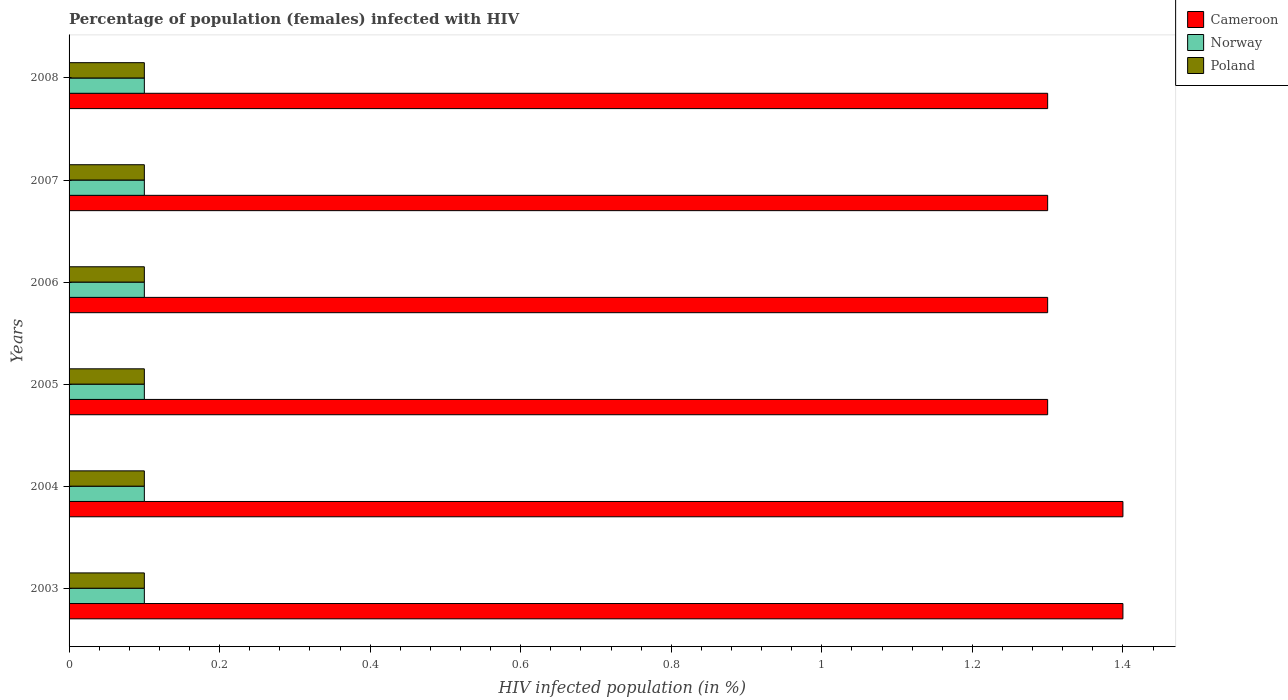How many different coloured bars are there?
Make the answer very short. 3. Are the number of bars per tick equal to the number of legend labels?
Provide a short and direct response. Yes. How many bars are there on the 1st tick from the top?
Provide a short and direct response. 3. What is the percentage of HIV infected female population in Norway in 2007?
Your answer should be compact. 0.1. In which year was the percentage of HIV infected female population in Poland maximum?
Your answer should be very brief. 2003. What is the total percentage of HIV infected female population in Cameroon in the graph?
Offer a very short reply. 8. What is the difference between the percentage of HIV infected female population in Norway in 2004 and the percentage of HIV infected female population in Poland in 2006?
Keep it short and to the point. 0. What is the average percentage of HIV infected female population in Norway per year?
Give a very brief answer. 0.1. In the year 2006, what is the difference between the percentage of HIV infected female population in Poland and percentage of HIV infected female population in Norway?
Offer a very short reply. 0. In how many years, is the percentage of HIV infected female population in Norway greater than 0.9600000000000001 %?
Your answer should be compact. 0. What is the ratio of the percentage of HIV infected female population in Cameroon in 2003 to that in 2005?
Ensure brevity in your answer.  1.08. Is the percentage of HIV infected female population in Cameroon in 2004 less than that in 2007?
Your answer should be very brief. No. Is the difference between the percentage of HIV infected female population in Poland in 2004 and 2008 greater than the difference between the percentage of HIV infected female population in Norway in 2004 and 2008?
Ensure brevity in your answer.  No. What is the difference between the highest and the lowest percentage of HIV infected female population in Cameroon?
Make the answer very short. 0.1. In how many years, is the percentage of HIV infected female population in Poland greater than the average percentage of HIV infected female population in Poland taken over all years?
Your answer should be very brief. 6. Is the sum of the percentage of HIV infected female population in Poland in 2005 and 2008 greater than the maximum percentage of HIV infected female population in Cameroon across all years?
Give a very brief answer. No. What does the 3rd bar from the top in 2008 represents?
Your response must be concise. Cameroon. Is it the case that in every year, the sum of the percentage of HIV infected female population in Norway and percentage of HIV infected female population in Poland is greater than the percentage of HIV infected female population in Cameroon?
Provide a short and direct response. No. How many bars are there?
Your answer should be compact. 18. Are all the bars in the graph horizontal?
Keep it short and to the point. Yes. How many years are there in the graph?
Offer a very short reply. 6. What is the difference between two consecutive major ticks on the X-axis?
Make the answer very short. 0.2. Does the graph contain grids?
Offer a terse response. No. Where does the legend appear in the graph?
Give a very brief answer. Top right. How many legend labels are there?
Provide a succinct answer. 3. How are the legend labels stacked?
Provide a short and direct response. Vertical. What is the title of the graph?
Your response must be concise. Percentage of population (females) infected with HIV. What is the label or title of the X-axis?
Give a very brief answer. HIV infected population (in %). What is the HIV infected population (in %) of Cameroon in 2004?
Ensure brevity in your answer.  1.4. What is the HIV infected population (in %) of Norway in 2004?
Give a very brief answer. 0.1. What is the HIV infected population (in %) in Poland in 2004?
Your response must be concise. 0.1. What is the HIV infected population (in %) in Cameroon in 2005?
Provide a short and direct response. 1.3. What is the HIV infected population (in %) of Norway in 2005?
Make the answer very short. 0.1. What is the HIV infected population (in %) of Poland in 2005?
Offer a very short reply. 0.1. What is the HIV infected population (in %) of Poland in 2006?
Your answer should be compact. 0.1. What is the HIV infected population (in %) of Poland in 2007?
Make the answer very short. 0.1. What is the HIV infected population (in %) in Norway in 2008?
Give a very brief answer. 0.1. Across all years, what is the maximum HIV infected population (in %) in Poland?
Offer a very short reply. 0.1. Across all years, what is the minimum HIV infected population (in %) of Norway?
Provide a succinct answer. 0.1. Across all years, what is the minimum HIV infected population (in %) of Poland?
Your answer should be compact. 0.1. What is the total HIV infected population (in %) of Norway in the graph?
Provide a succinct answer. 0.6. What is the difference between the HIV infected population (in %) in Cameroon in 2003 and that in 2004?
Provide a short and direct response. 0. What is the difference between the HIV infected population (in %) of Norway in 2003 and that in 2004?
Offer a terse response. 0. What is the difference between the HIV infected population (in %) of Cameroon in 2003 and that in 2005?
Provide a succinct answer. 0.1. What is the difference between the HIV infected population (in %) in Poland in 2003 and that in 2005?
Your answer should be compact. 0. What is the difference between the HIV infected population (in %) of Norway in 2003 and that in 2006?
Offer a terse response. 0. What is the difference between the HIV infected population (in %) of Poland in 2003 and that in 2006?
Keep it short and to the point. 0. What is the difference between the HIV infected population (in %) of Norway in 2003 and that in 2007?
Make the answer very short. 0. What is the difference between the HIV infected population (in %) in Cameroon in 2003 and that in 2008?
Your answer should be very brief. 0.1. What is the difference between the HIV infected population (in %) of Norway in 2003 and that in 2008?
Ensure brevity in your answer.  0. What is the difference between the HIV infected population (in %) in Cameroon in 2004 and that in 2005?
Ensure brevity in your answer.  0.1. What is the difference between the HIV infected population (in %) of Poland in 2004 and that in 2005?
Your answer should be compact. 0. What is the difference between the HIV infected population (in %) in Cameroon in 2004 and that in 2006?
Your answer should be very brief. 0.1. What is the difference between the HIV infected population (in %) of Poland in 2004 and that in 2006?
Give a very brief answer. 0. What is the difference between the HIV infected population (in %) of Cameroon in 2004 and that in 2007?
Offer a terse response. 0.1. What is the difference between the HIV infected population (in %) of Norway in 2004 and that in 2007?
Make the answer very short. 0. What is the difference between the HIV infected population (in %) of Norway in 2004 and that in 2008?
Ensure brevity in your answer.  0. What is the difference between the HIV infected population (in %) in Poland in 2004 and that in 2008?
Keep it short and to the point. 0. What is the difference between the HIV infected population (in %) in Cameroon in 2005 and that in 2006?
Your answer should be compact. 0. What is the difference between the HIV infected population (in %) in Norway in 2005 and that in 2006?
Your answer should be very brief. 0. What is the difference between the HIV infected population (in %) in Poland in 2005 and that in 2006?
Offer a very short reply. 0. What is the difference between the HIV infected population (in %) of Norway in 2005 and that in 2007?
Your answer should be very brief. 0. What is the difference between the HIV infected population (in %) of Cameroon in 2005 and that in 2008?
Provide a succinct answer. 0. What is the difference between the HIV infected population (in %) of Norway in 2005 and that in 2008?
Offer a terse response. 0. What is the difference between the HIV infected population (in %) of Poland in 2005 and that in 2008?
Offer a terse response. 0. What is the difference between the HIV infected population (in %) of Cameroon in 2006 and that in 2007?
Your answer should be compact. 0. What is the difference between the HIV infected population (in %) in Norway in 2006 and that in 2007?
Offer a very short reply. 0. What is the difference between the HIV infected population (in %) of Cameroon in 2007 and that in 2008?
Provide a short and direct response. 0. What is the difference between the HIV infected population (in %) in Norway in 2007 and that in 2008?
Offer a terse response. 0. What is the difference between the HIV infected population (in %) in Cameroon in 2003 and the HIV infected population (in %) in Norway in 2004?
Offer a terse response. 1.3. What is the difference between the HIV infected population (in %) of Norway in 2003 and the HIV infected population (in %) of Poland in 2004?
Provide a succinct answer. 0. What is the difference between the HIV infected population (in %) of Cameroon in 2003 and the HIV infected population (in %) of Norway in 2006?
Your response must be concise. 1.3. What is the difference between the HIV infected population (in %) of Cameroon in 2003 and the HIV infected population (in %) of Poland in 2006?
Offer a terse response. 1.3. What is the difference between the HIV infected population (in %) in Norway in 2003 and the HIV infected population (in %) in Poland in 2006?
Your response must be concise. 0. What is the difference between the HIV infected population (in %) of Cameroon in 2003 and the HIV infected population (in %) of Norway in 2007?
Give a very brief answer. 1.3. What is the difference between the HIV infected population (in %) of Norway in 2003 and the HIV infected population (in %) of Poland in 2007?
Your answer should be compact. 0. What is the difference between the HIV infected population (in %) in Cameroon in 2003 and the HIV infected population (in %) in Poland in 2008?
Your response must be concise. 1.3. What is the difference between the HIV infected population (in %) of Norway in 2004 and the HIV infected population (in %) of Poland in 2005?
Offer a very short reply. 0. What is the difference between the HIV infected population (in %) of Cameroon in 2004 and the HIV infected population (in %) of Norway in 2006?
Your response must be concise. 1.3. What is the difference between the HIV infected population (in %) of Norway in 2004 and the HIV infected population (in %) of Poland in 2006?
Give a very brief answer. 0. What is the difference between the HIV infected population (in %) of Cameroon in 2004 and the HIV infected population (in %) of Norway in 2007?
Your answer should be very brief. 1.3. What is the difference between the HIV infected population (in %) in Cameroon in 2004 and the HIV infected population (in %) in Poland in 2007?
Offer a terse response. 1.3. What is the difference between the HIV infected population (in %) in Cameroon in 2004 and the HIV infected population (in %) in Poland in 2008?
Ensure brevity in your answer.  1.3. What is the difference between the HIV infected population (in %) in Norway in 2004 and the HIV infected population (in %) in Poland in 2008?
Make the answer very short. 0. What is the difference between the HIV infected population (in %) of Cameroon in 2005 and the HIV infected population (in %) of Poland in 2006?
Your answer should be compact. 1.2. What is the difference between the HIV infected population (in %) in Norway in 2005 and the HIV infected population (in %) in Poland in 2006?
Provide a short and direct response. 0. What is the difference between the HIV infected population (in %) of Cameroon in 2005 and the HIV infected population (in %) of Poland in 2007?
Give a very brief answer. 1.2. What is the difference between the HIV infected population (in %) in Norway in 2005 and the HIV infected population (in %) in Poland in 2007?
Offer a terse response. 0. What is the difference between the HIV infected population (in %) in Cameroon in 2005 and the HIV infected population (in %) in Poland in 2008?
Keep it short and to the point. 1.2. What is the difference between the HIV infected population (in %) of Cameroon in 2006 and the HIV infected population (in %) of Norway in 2007?
Keep it short and to the point. 1.2. What is the difference between the HIV infected population (in %) in Cameroon in 2006 and the HIV infected population (in %) in Norway in 2008?
Provide a succinct answer. 1.2. What is the difference between the HIV infected population (in %) of Cameroon in 2007 and the HIV infected population (in %) of Poland in 2008?
Offer a terse response. 1.2. What is the average HIV infected population (in %) in Poland per year?
Provide a short and direct response. 0.1. In the year 2003, what is the difference between the HIV infected population (in %) of Norway and HIV infected population (in %) of Poland?
Ensure brevity in your answer.  0. In the year 2004, what is the difference between the HIV infected population (in %) in Cameroon and HIV infected population (in %) in Poland?
Your answer should be compact. 1.3. In the year 2005, what is the difference between the HIV infected population (in %) in Cameroon and HIV infected population (in %) in Norway?
Offer a terse response. 1.2. In the year 2005, what is the difference between the HIV infected population (in %) in Norway and HIV infected population (in %) in Poland?
Keep it short and to the point. 0. In the year 2006, what is the difference between the HIV infected population (in %) of Cameroon and HIV infected population (in %) of Poland?
Give a very brief answer. 1.2. In the year 2006, what is the difference between the HIV infected population (in %) of Norway and HIV infected population (in %) of Poland?
Your answer should be very brief. 0. In the year 2007, what is the difference between the HIV infected population (in %) in Cameroon and HIV infected population (in %) in Norway?
Your answer should be very brief. 1.2. In the year 2007, what is the difference between the HIV infected population (in %) in Cameroon and HIV infected population (in %) in Poland?
Your answer should be very brief. 1.2. In the year 2008, what is the difference between the HIV infected population (in %) in Cameroon and HIV infected population (in %) in Norway?
Keep it short and to the point. 1.2. In the year 2008, what is the difference between the HIV infected population (in %) of Cameroon and HIV infected population (in %) of Poland?
Keep it short and to the point. 1.2. What is the ratio of the HIV infected population (in %) in Cameroon in 2003 to that in 2004?
Your answer should be very brief. 1. What is the ratio of the HIV infected population (in %) of Poland in 2003 to that in 2004?
Your answer should be compact. 1. What is the ratio of the HIV infected population (in %) in Cameroon in 2003 to that in 2005?
Ensure brevity in your answer.  1.08. What is the ratio of the HIV infected population (in %) of Poland in 2003 to that in 2005?
Keep it short and to the point. 1. What is the ratio of the HIV infected population (in %) in Cameroon in 2003 to that in 2007?
Offer a terse response. 1.08. What is the ratio of the HIV infected population (in %) in Norway in 2003 to that in 2007?
Offer a terse response. 1. What is the ratio of the HIV infected population (in %) of Poland in 2003 to that in 2007?
Keep it short and to the point. 1. What is the ratio of the HIV infected population (in %) in Cameroon in 2003 to that in 2008?
Keep it short and to the point. 1.08. What is the ratio of the HIV infected population (in %) of Poland in 2004 to that in 2005?
Your answer should be very brief. 1. What is the ratio of the HIV infected population (in %) of Cameroon in 2004 to that in 2006?
Make the answer very short. 1.08. What is the ratio of the HIV infected population (in %) in Poland in 2004 to that in 2006?
Give a very brief answer. 1. What is the ratio of the HIV infected population (in %) in Cameroon in 2004 to that in 2007?
Keep it short and to the point. 1.08. What is the ratio of the HIV infected population (in %) in Norway in 2004 to that in 2007?
Offer a terse response. 1. What is the ratio of the HIV infected population (in %) of Cameroon in 2004 to that in 2008?
Your answer should be compact. 1.08. What is the ratio of the HIV infected population (in %) of Norway in 2004 to that in 2008?
Make the answer very short. 1. What is the ratio of the HIV infected population (in %) in Poland in 2004 to that in 2008?
Your answer should be very brief. 1. What is the ratio of the HIV infected population (in %) in Cameroon in 2005 to that in 2006?
Keep it short and to the point. 1. What is the ratio of the HIV infected population (in %) of Norway in 2005 to that in 2006?
Give a very brief answer. 1. What is the ratio of the HIV infected population (in %) in Poland in 2005 to that in 2006?
Keep it short and to the point. 1. What is the ratio of the HIV infected population (in %) in Cameroon in 2005 to that in 2007?
Provide a succinct answer. 1. What is the ratio of the HIV infected population (in %) in Norway in 2005 to that in 2007?
Offer a very short reply. 1. What is the ratio of the HIV infected population (in %) in Poland in 2005 to that in 2007?
Keep it short and to the point. 1. What is the ratio of the HIV infected population (in %) in Norway in 2006 to that in 2007?
Your answer should be very brief. 1. What is the ratio of the HIV infected population (in %) in Poland in 2006 to that in 2008?
Your response must be concise. 1. What is the ratio of the HIV infected population (in %) of Cameroon in 2007 to that in 2008?
Offer a terse response. 1. What is the ratio of the HIV infected population (in %) of Norway in 2007 to that in 2008?
Offer a very short reply. 1. What is the ratio of the HIV infected population (in %) of Poland in 2007 to that in 2008?
Your answer should be very brief. 1. What is the difference between the highest and the lowest HIV infected population (in %) of Cameroon?
Ensure brevity in your answer.  0.1. What is the difference between the highest and the lowest HIV infected population (in %) in Poland?
Ensure brevity in your answer.  0. 